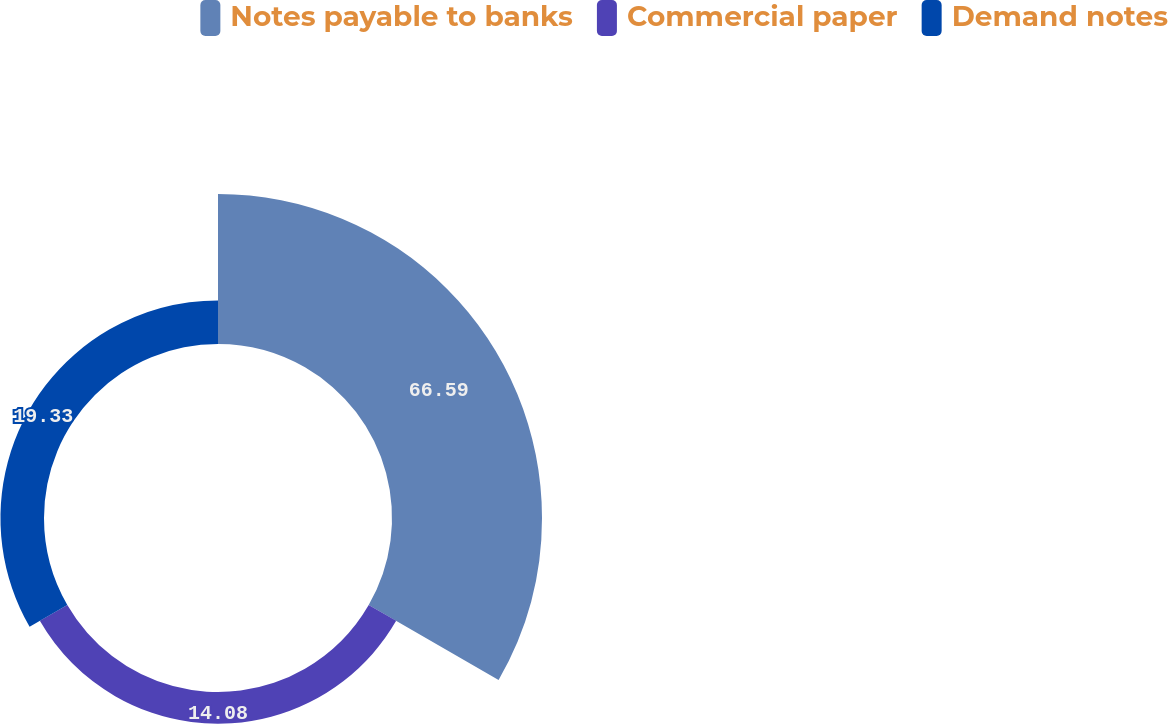Convert chart to OTSL. <chart><loc_0><loc_0><loc_500><loc_500><pie_chart><fcel>Notes payable to banks<fcel>Commercial paper<fcel>Demand notes<nl><fcel>66.58%<fcel>14.08%<fcel>19.33%<nl></chart> 